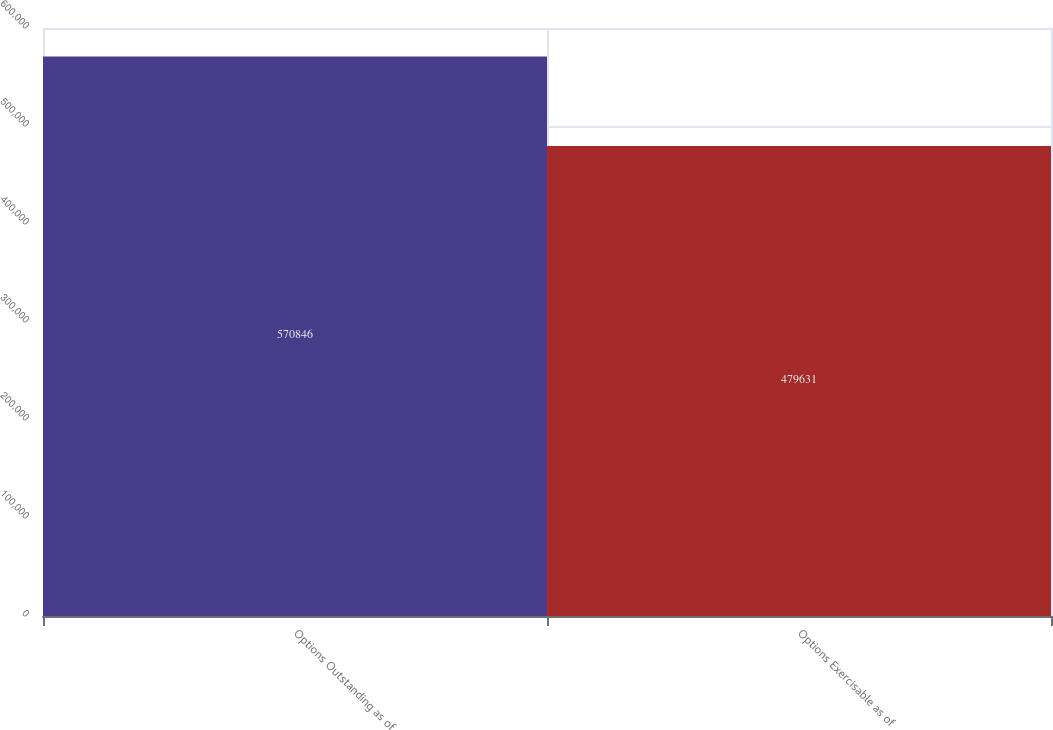Convert chart. <chart><loc_0><loc_0><loc_500><loc_500><bar_chart><fcel>Options Outstanding as of<fcel>Options Exercisable as of<nl><fcel>570846<fcel>479631<nl></chart> 